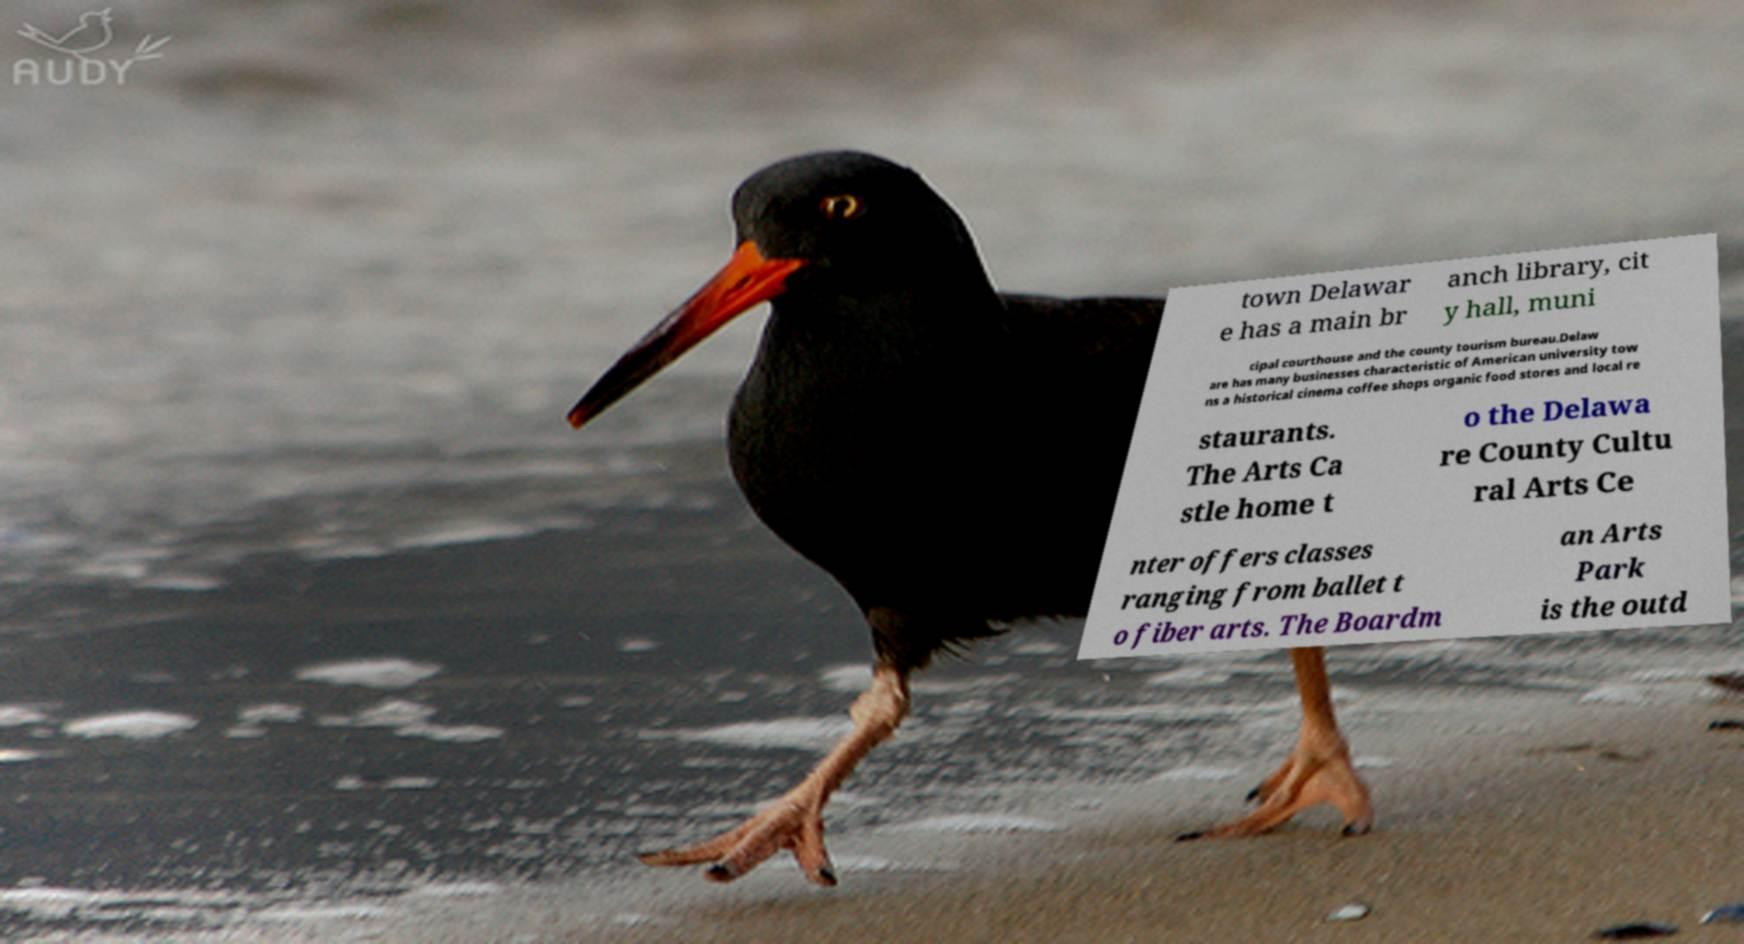Could you extract and type out the text from this image? town Delawar e has a main br anch library, cit y hall, muni cipal courthouse and the county tourism bureau.Delaw are has many businesses characteristic of American university tow ns a historical cinema coffee shops organic food stores and local re staurants. The Arts Ca stle home t o the Delawa re County Cultu ral Arts Ce nter offers classes ranging from ballet t o fiber arts. The Boardm an Arts Park is the outd 